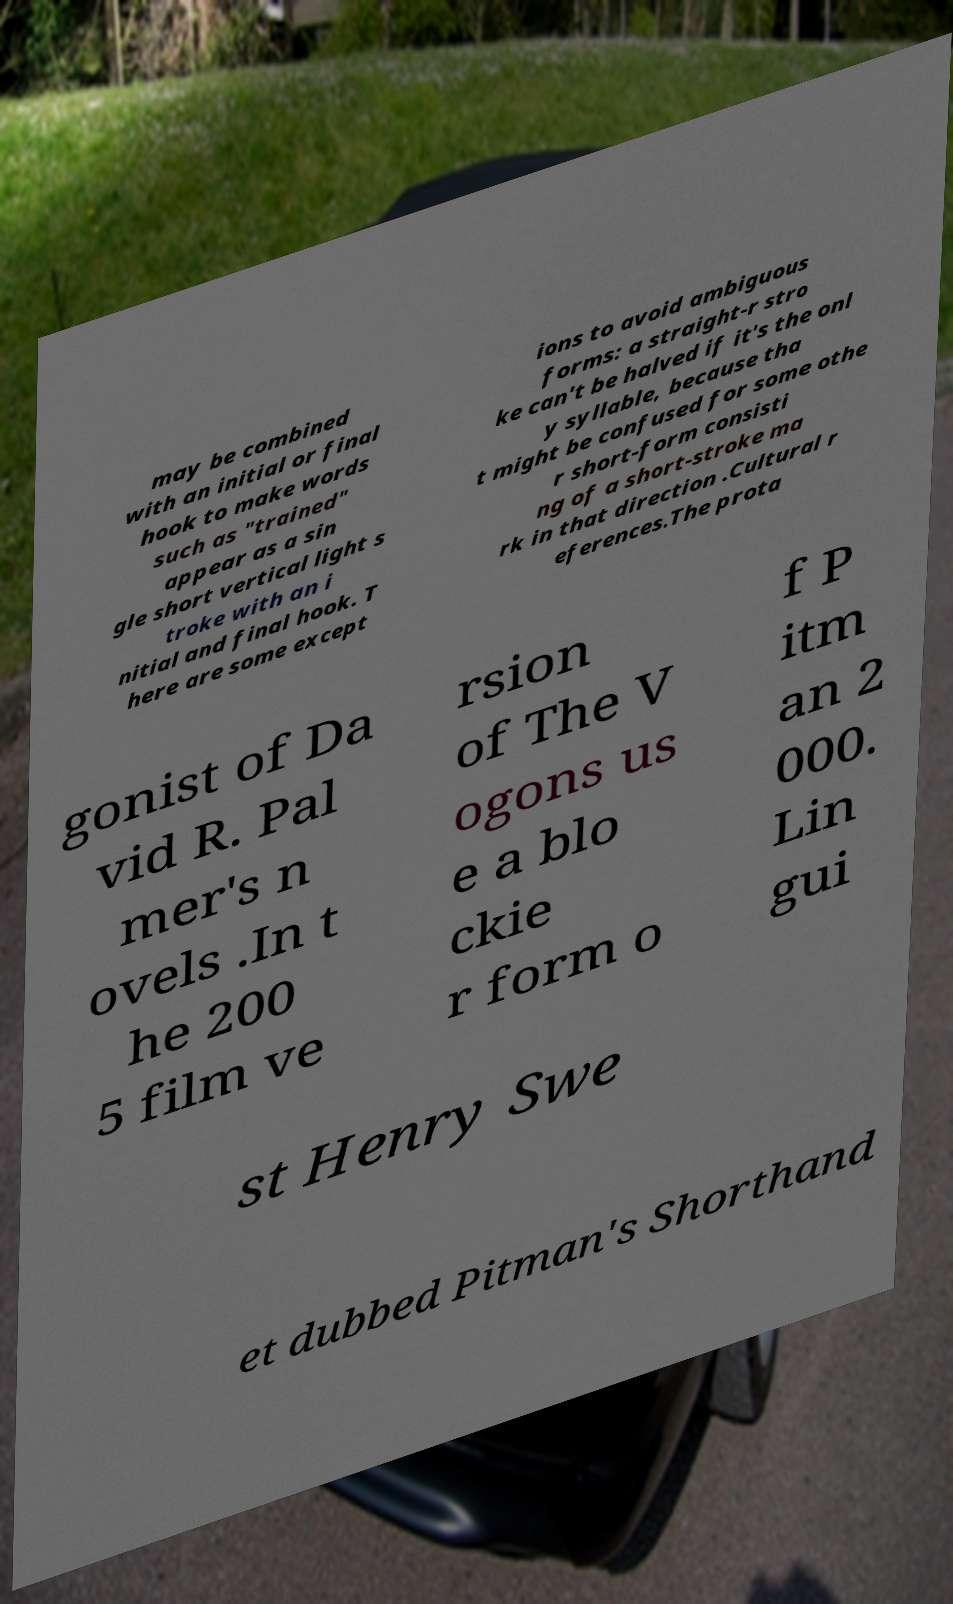Please read and relay the text visible in this image. What does it say? may be combined with an initial or final hook to make words such as "trained" appear as a sin gle short vertical light s troke with an i nitial and final hook. T here are some except ions to avoid ambiguous forms: a straight-r stro ke can't be halved if it's the onl y syllable, because tha t might be confused for some othe r short-form consisti ng of a short-stroke ma rk in that direction .Cultural r eferences.The prota gonist of Da vid R. Pal mer's n ovels .In t he 200 5 film ve rsion of The V ogons us e a blo ckie r form o f P itm an 2 000. Lin gui st Henry Swe et dubbed Pitman's Shorthand 